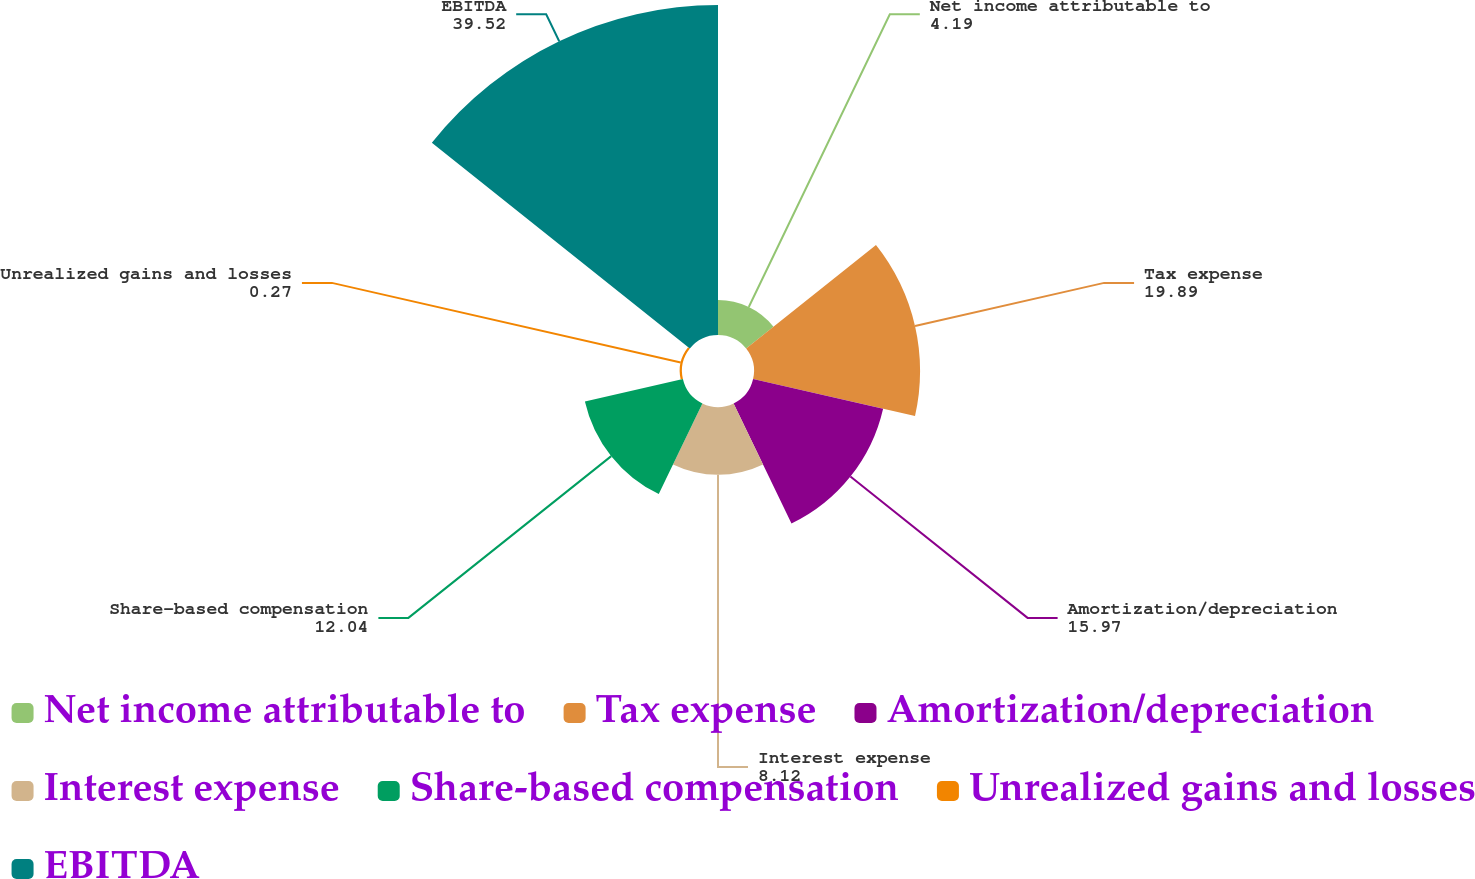Convert chart to OTSL. <chart><loc_0><loc_0><loc_500><loc_500><pie_chart><fcel>Net income attributable to<fcel>Tax expense<fcel>Amortization/depreciation<fcel>Interest expense<fcel>Share-based compensation<fcel>Unrealized gains and losses<fcel>EBITDA<nl><fcel>4.19%<fcel>19.89%<fcel>15.97%<fcel>8.12%<fcel>12.04%<fcel>0.27%<fcel>39.52%<nl></chart> 